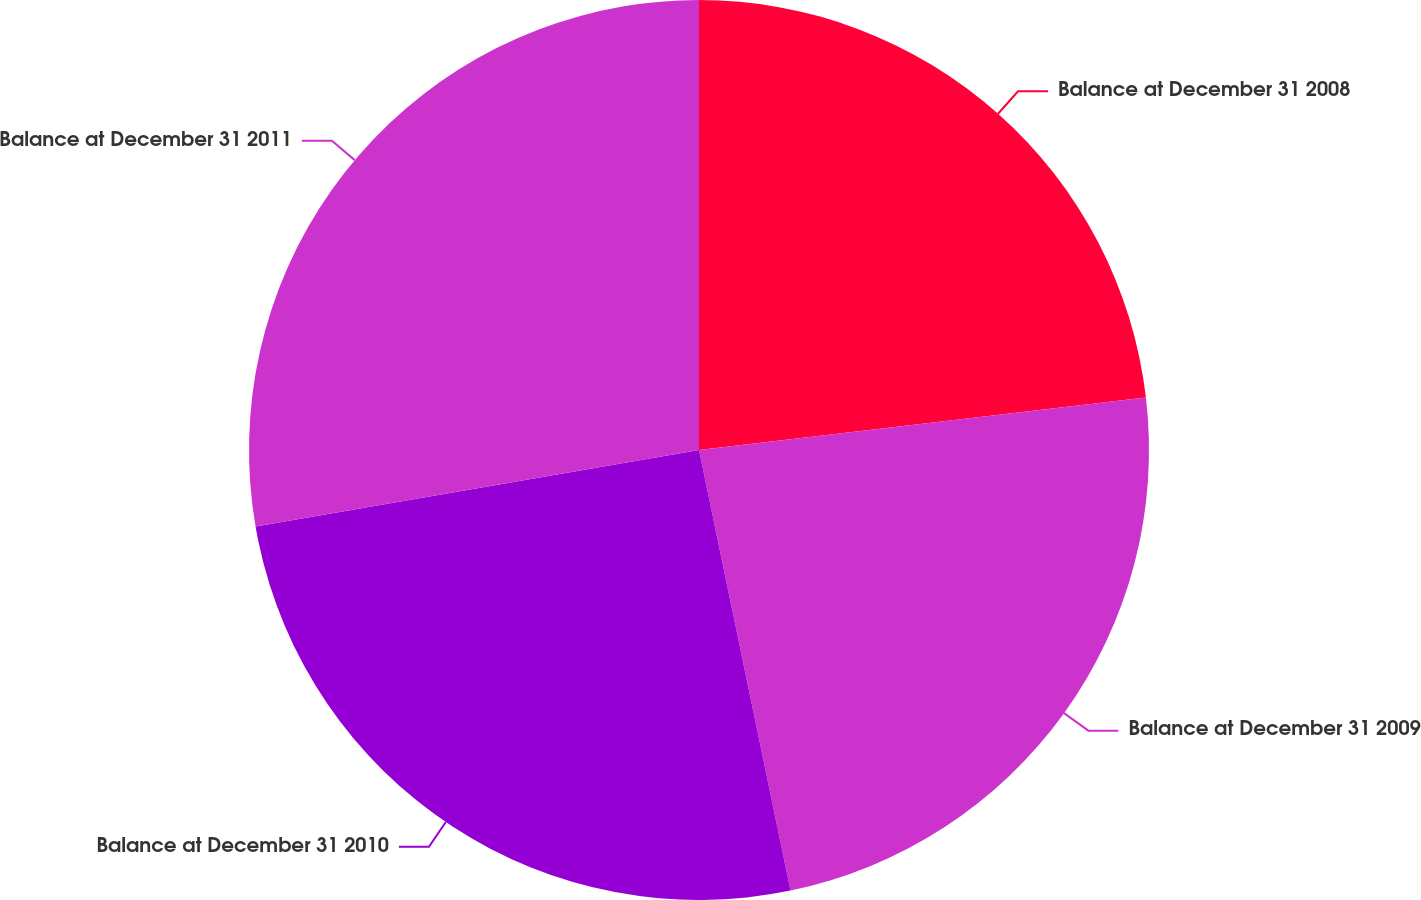Convert chart to OTSL. <chart><loc_0><loc_0><loc_500><loc_500><pie_chart><fcel>Balance at December 31 2008<fcel>Balance at December 31 2009<fcel>Balance at December 31 2010<fcel>Balance at December 31 2011<nl><fcel>23.14%<fcel>23.6%<fcel>25.54%<fcel>27.72%<nl></chart> 